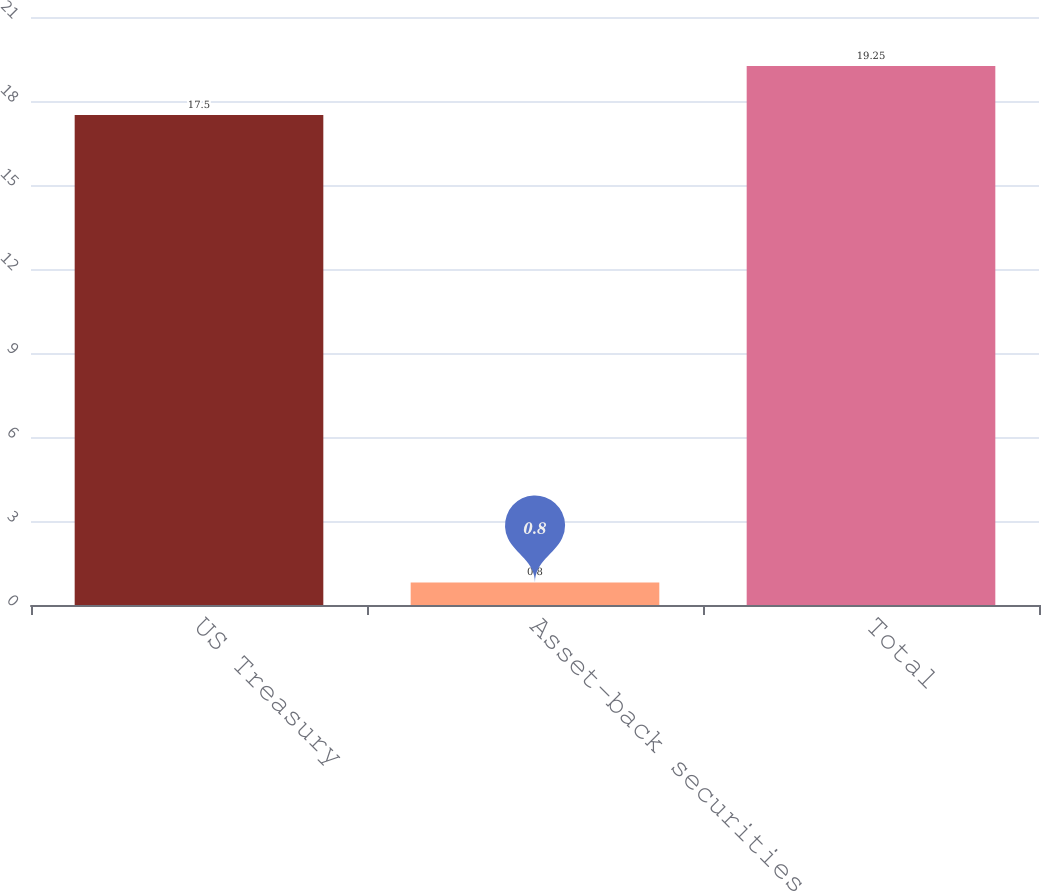Convert chart. <chart><loc_0><loc_0><loc_500><loc_500><bar_chart><fcel>US Treasury<fcel>Asset-back securities<fcel>Total<nl><fcel>17.5<fcel>0.8<fcel>19.25<nl></chart> 